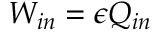<formula> <loc_0><loc_0><loc_500><loc_500>W _ { i n } = \epsilon Q _ { i n }</formula> 